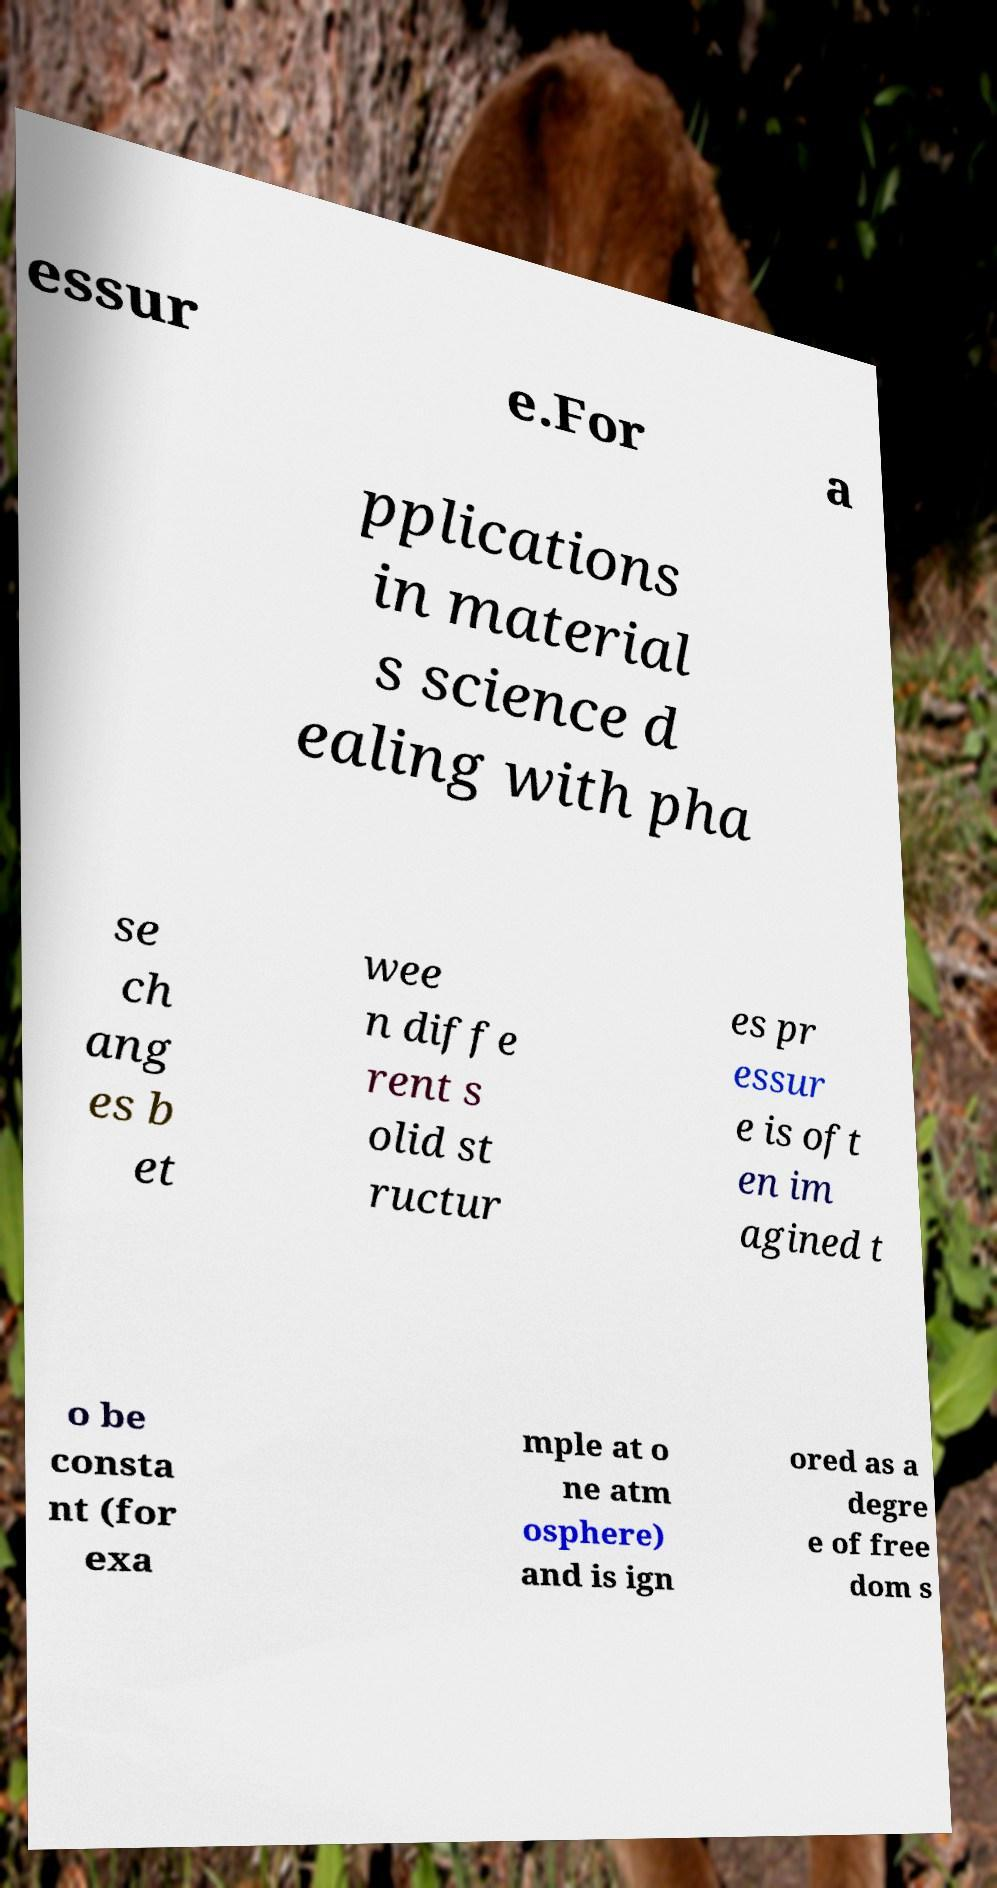For documentation purposes, I need the text within this image transcribed. Could you provide that? essur e.For a pplications in material s science d ealing with pha se ch ang es b et wee n diffe rent s olid st ructur es pr essur e is oft en im agined t o be consta nt (for exa mple at o ne atm osphere) and is ign ored as a degre e of free dom s 